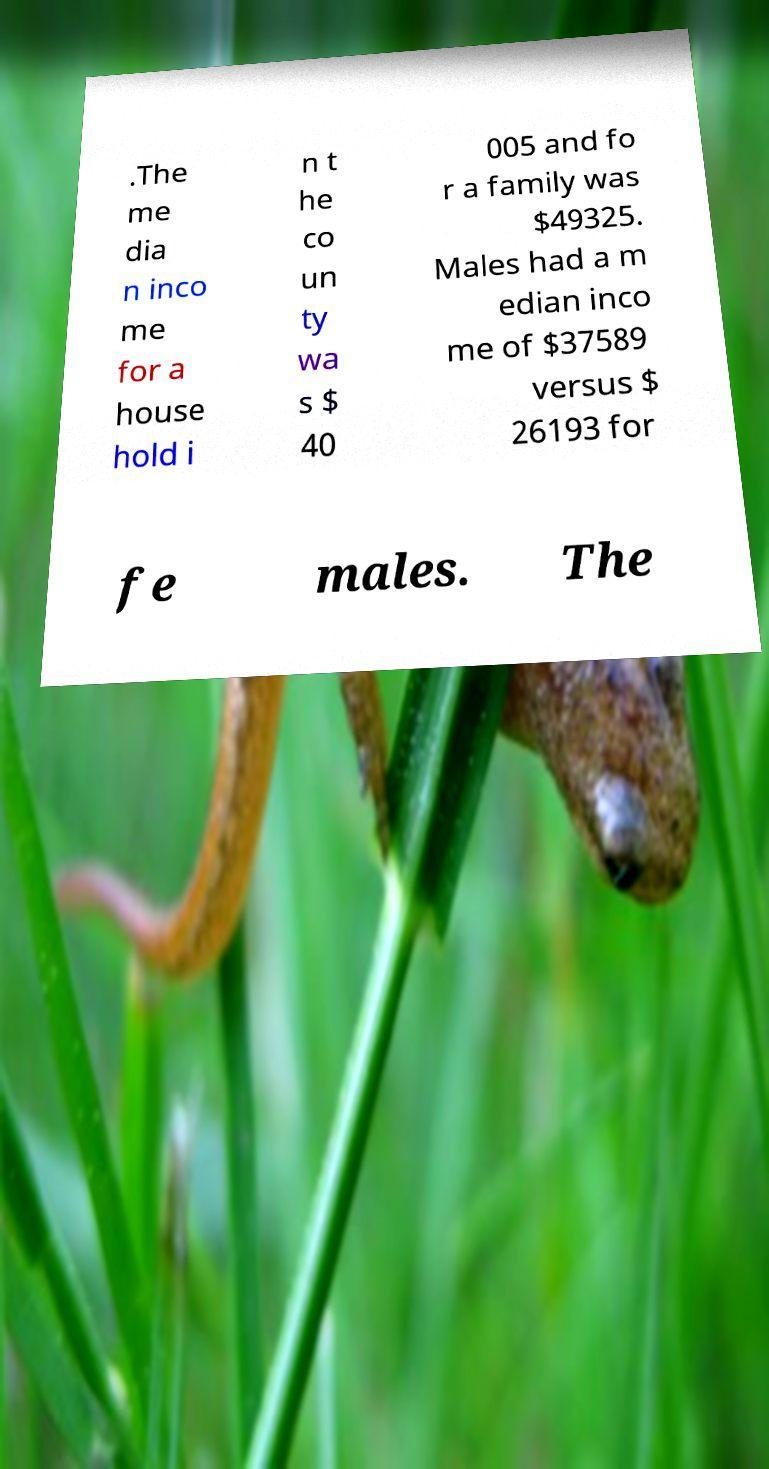There's text embedded in this image that I need extracted. Can you transcribe it verbatim? .The me dia n inco me for a house hold i n t he co un ty wa s $ 40 005 and fo r a family was $49325. Males had a m edian inco me of $37589 versus $ 26193 for fe males. The 